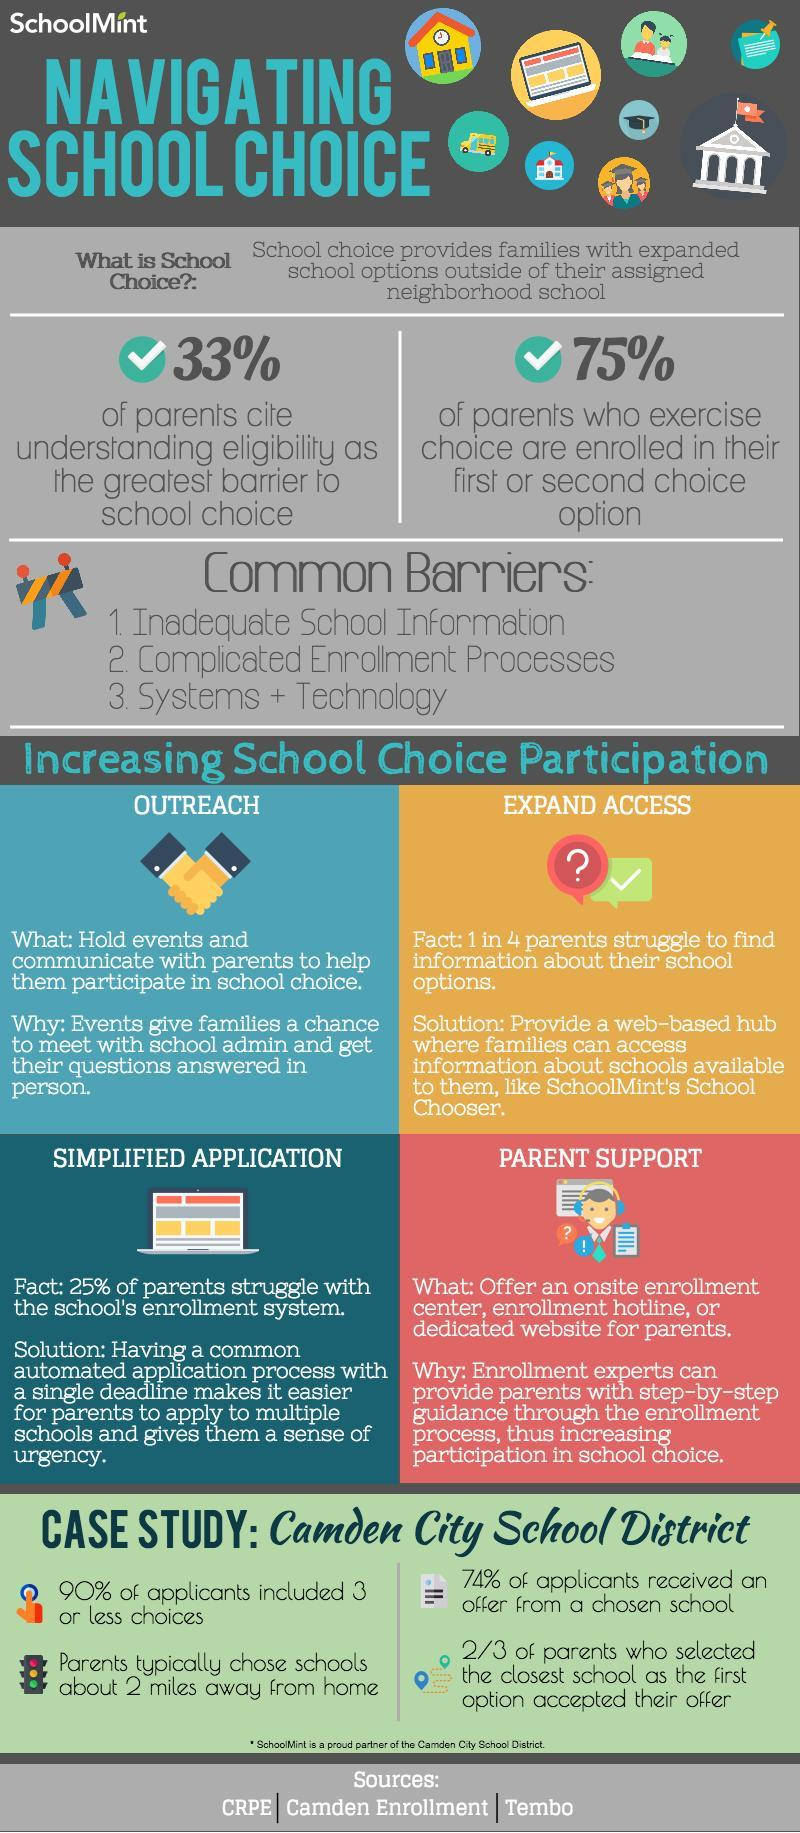What percentage of parents of parents do not cite understanding eligibility as the barrier to school choice?
Answer the question with a short phrase. 67% What percentage of parents do not choose the first or second choice of schools given in their options? 25% What percentage of applicants choose more three 3 schools in their options? 10% What percentage of applicants did not receive offer from the chosen school? 24% 